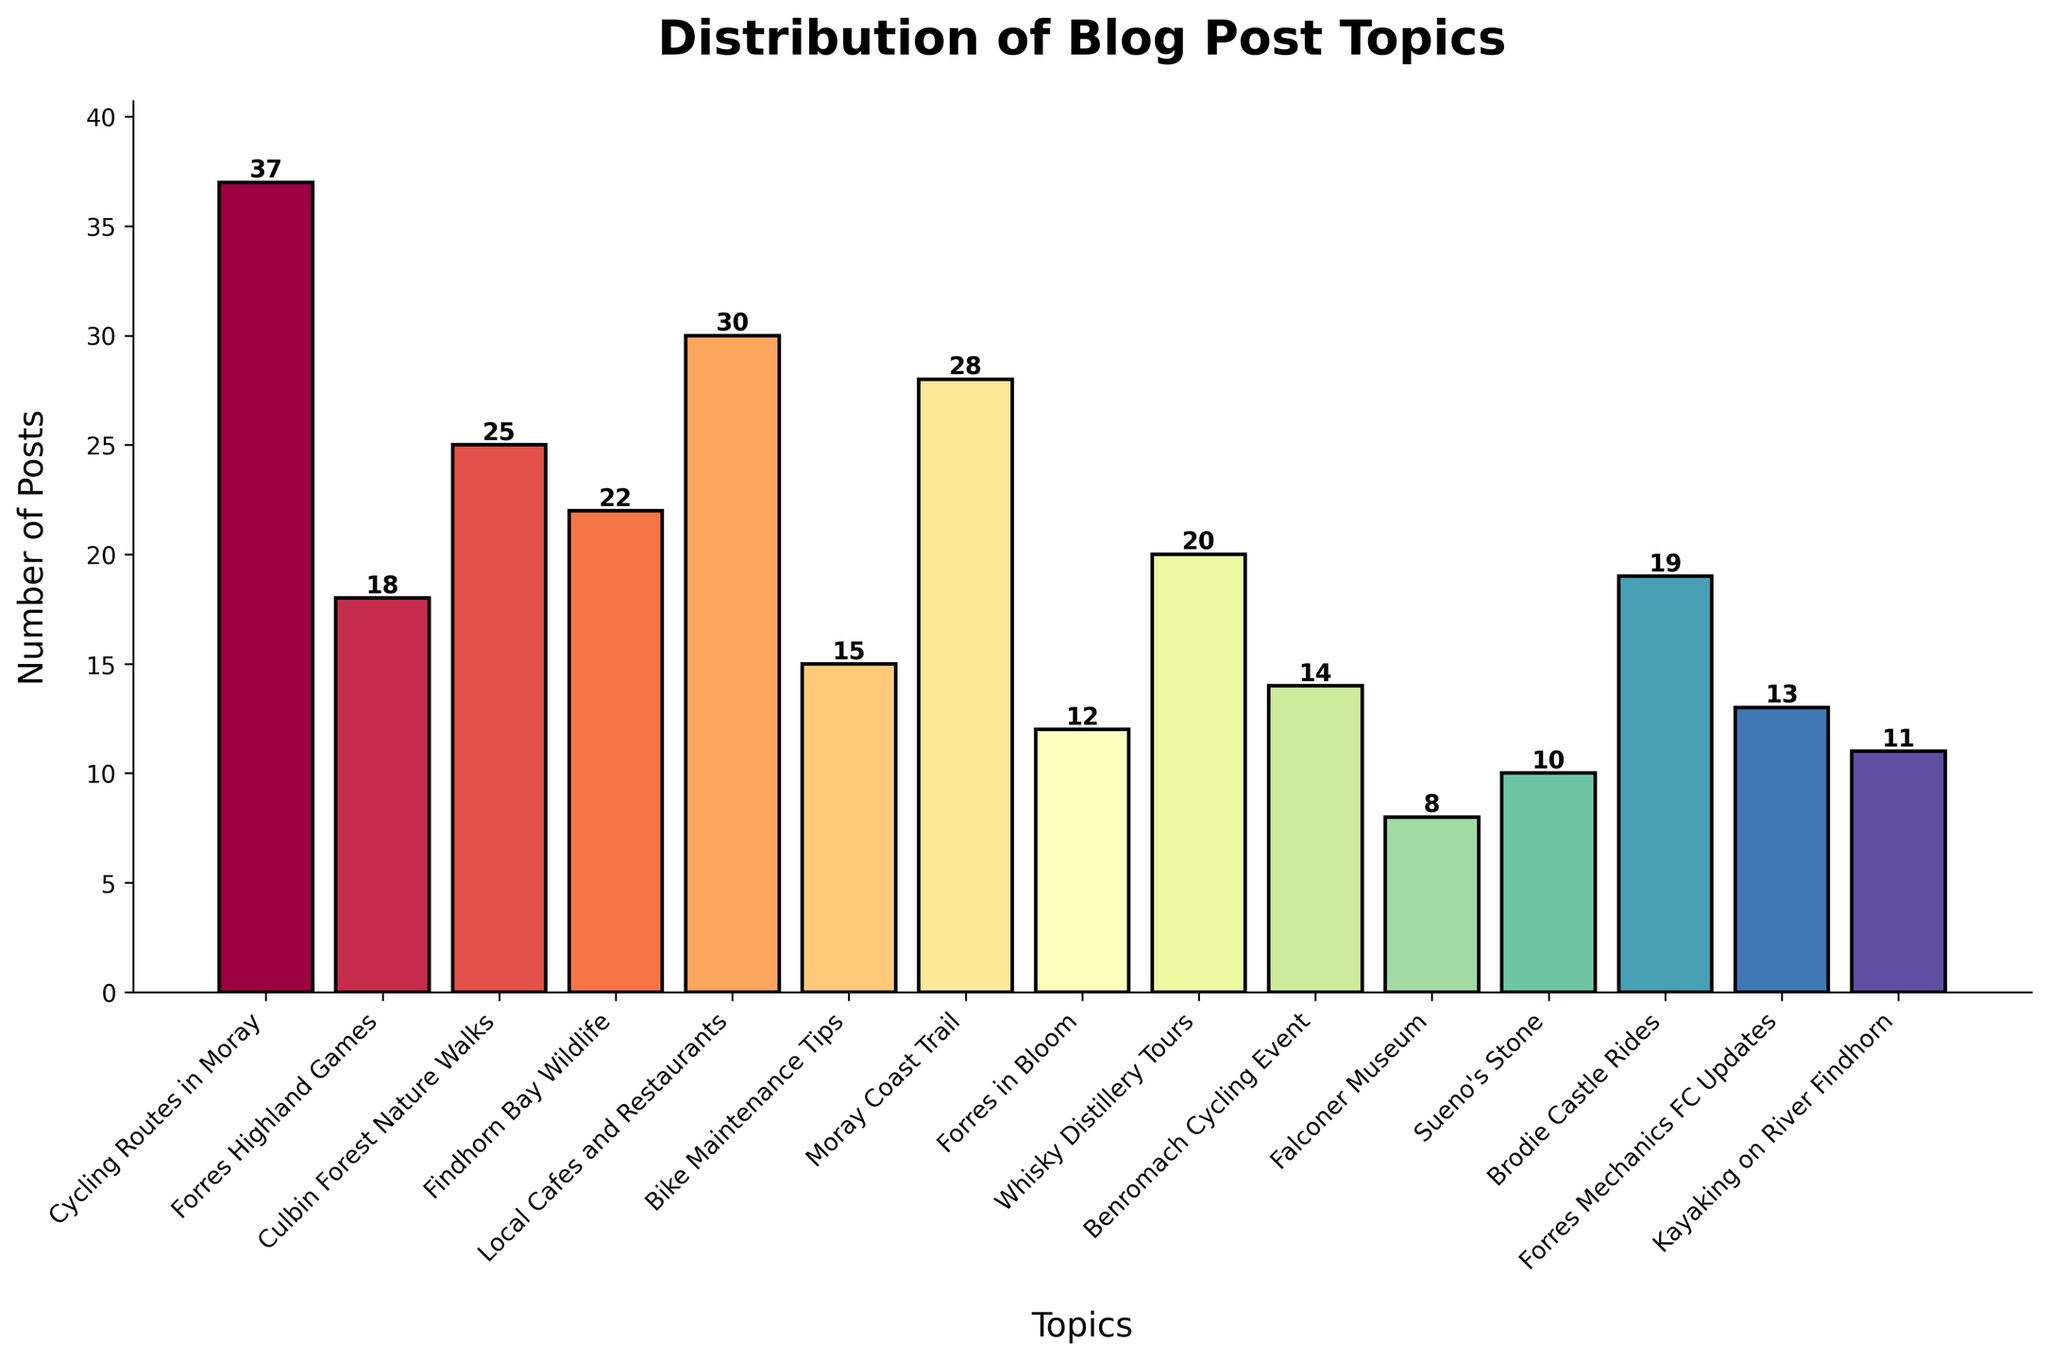What is the most frequently discussed topic on the blog? The bar chart shows the number of posts for each topic. The bar for "Cycling Routes in Moray" is the tallest, indicating it has the highest number of posts, which is 37.
Answer: Cycling Routes in Moray Which topic has the least number of posts? By examining the bar chart, the bar for "Falconer Museum" appears the shortest, indicating it has the fewest posts, which is 8.
Answer: Falconer Museum How many more posts are there about local cafes and restaurants compared to Forres Mechanics FC updates? The number of posts for "Local Cafes and Restaurants" is 30, and for "Forres Mechanics FC Updates" is 13. The difference is 30 - 13 = 17.
Answer: 17 Is the number of posts about whisky distillery tours greater or less than the number of posts about kayaking on River Findhorn? Comparing the heights of the bars, "Whisky Distillery Tours" has 20 posts while "Kayaking on River Findhorn" has 11 posts. 20 is greater than 11.
Answer: Greater What is the combined total number of posts for topics related to cycling (Cycling Routes in Moray, Bike Maintenance Tips, Benromach Cycling Event, Brodie Castle Rides)? Add the number of posts for each cycling-related topic: 37 (Cycling Routes in Moray) + 15 (Bike Maintenance Tips) + 14 (Benromach Cycling Event) + 19 (Brodie Castle Rides). The total is 37 + 15 + 14 + 19 = 85.
Answer: 85 Which topic has just over half the number of posts as "Local Cafes and Restaurants"? "Local Cafes and Restaurants" has 30 posts. Half of 30 is 15. Examining the chart, "Bike Maintenance Tips" has 15 posts.
Answer: Bike Maintenance Tips Among Culbin Forest Nature Walks, Findhorn Bay Wildlife, and Moray Coast Trail, which topic has the highest number of posts? Reviewing the heights of the bars, "Culbin Forest Nature Walks" has 25 posts, "Findhorn Bay Wildlife" has 22 posts, and "Moray Coast Trail" has 28 posts. The highest number among these is 28 for "Moray Coast Trail".
Answer: Moray Coast Trail What is the average number of posts per topic? Sum up the number of posts for all topics, which gives 292. There are 15 topics. The average is then 292/15 = 19.47 (rounded to two decimal places).
Answer: 19.47 Which topic has fewer posts: Forres in Bloom or Sueno's Stone? Comparing the bars for "Forres in Bloom" and "Sueno's Stone", "Forres in Bloom" has 12 posts, and "Sueno's Stone" has 10 posts. 10 is fewer than 12.
Answer: Sueno's Stone 